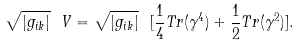Convert formula to latex. <formula><loc_0><loc_0><loc_500><loc_500>\sqrt { | g _ { i k } | } \ V = \sqrt { | g _ { i k } | } \ [ \frac { 1 } { 4 } T r ( \gamma ^ { 4 } ) + \frac { 1 } { 2 } T r ( \gamma ^ { 2 } ) ] .</formula> 